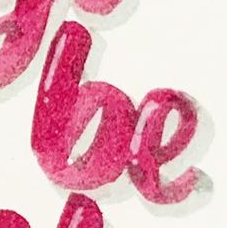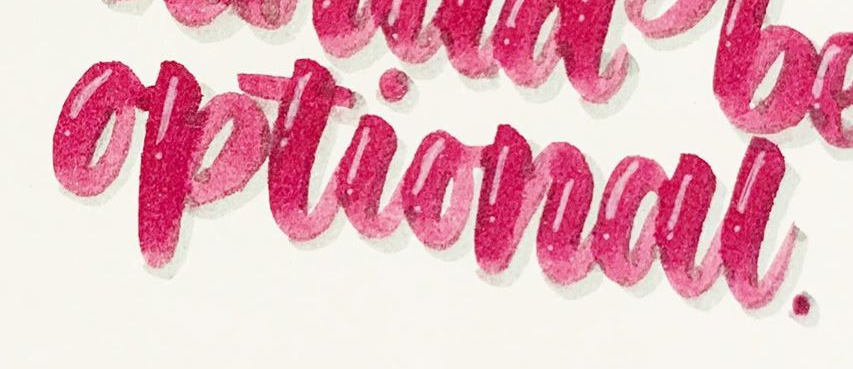Identify the words shown in these images in order, separated by a semicolon. be; optional 